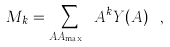Convert formula to latex. <formula><loc_0><loc_0><loc_500><loc_500>M _ { k } = \sum _ { A \neq A _ { \max } } A ^ { k } Y ( A ) \ ,</formula> 